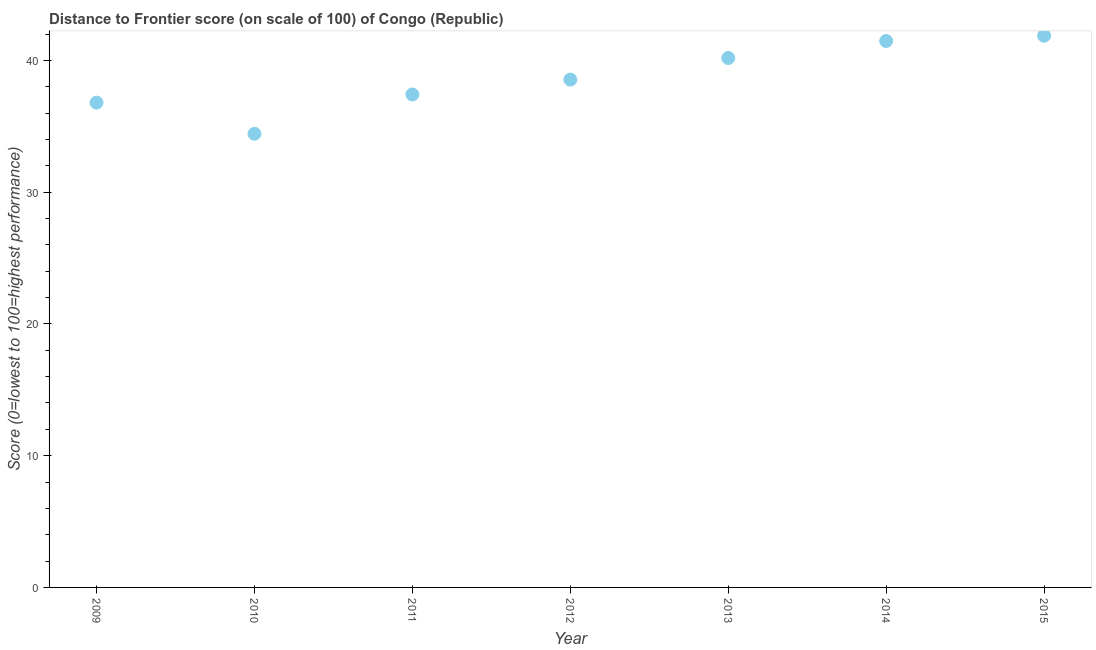What is the distance to frontier score in 2011?
Give a very brief answer. 37.42. Across all years, what is the maximum distance to frontier score?
Make the answer very short. 41.88. Across all years, what is the minimum distance to frontier score?
Provide a short and direct response. 34.44. In which year was the distance to frontier score maximum?
Provide a succinct answer. 2015. What is the sum of the distance to frontier score?
Your response must be concise. 270.76. What is the difference between the distance to frontier score in 2011 and 2014?
Keep it short and to the point. -4.06. What is the average distance to frontier score per year?
Your answer should be compact. 38.68. What is the median distance to frontier score?
Your answer should be very brief. 38.55. In how many years, is the distance to frontier score greater than 4 ?
Give a very brief answer. 7. Do a majority of the years between 2011 and 2013 (inclusive) have distance to frontier score greater than 30 ?
Offer a terse response. Yes. What is the ratio of the distance to frontier score in 2013 to that in 2014?
Your answer should be very brief. 0.97. Is the distance to frontier score in 2011 less than that in 2012?
Provide a succinct answer. Yes. What is the difference between the highest and the second highest distance to frontier score?
Offer a terse response. 0.4. What is the difference between the highest and the lowest distance to frontier score?
Your response must be concise. 7.44. Does the distance to frontier score monotonically increase over the years?
Offer a terse response. No. How many dotlines are there?
Keep it short and to the point. 1. How many years are there in the graph?
Your response must be concise. 7. Does the graph contain any zero values?
Your answer should be compact. No. What is the title of the graph?
Your answer should be very brief. Distance to Frontier score (on scale of 100) of Congo (Republic). What is the label or title of the X-axis?
Give a very brief answer. Year. What is the label or title of the Y-axis?
Make the answer very short. Score (0=lowest to 100=highest performance). What is the Score (0=lowest to 100=highest performance) in 2009?
Provide a succinct answer. 36.8. What is the Score (0=lowest to 100=highest performance) in 2010?
Give a very brief answer. 34.44. What is the Score (0=lowest to 100=highest performance) in 2011?
Offer a terse response. 37.42. What is the Score (0=lowest to 100=highest performance) in 2012?
Keep it short and to the point. 38.55. What is the Score (0=lowest to 100=highest performance) in 2013?
Offer a very short reply. 40.19. What is the Score (0=lowest to 100=highest performance) in 2014?
Provide a succinct answer. 41.48. What is the Score (0=lowest to 100=highest performance) in 2015?
Your answer should be very brief. 41.88. What is the difference between the Score (0=lowest to 100=highest performance) in 2009 and 2010?
Your answer should be compact. 2.36. What is the difference between the Score (0=lowest to 100=highest performance) in 2009 and 2011?
Offer a terse response. -0.62. What is the difference between the Score (0=lowest to 100=highest performance) in 2009 and 2012?
Ensure brevity in your answer.  -1.75. What is the difference between the Score (0=lowest to 100=highest performance) in 2009 and 2013?
Your answer should be compact. -3.39. What is the difference between the Score (0=lowest to 100=highest performance) in 2009 and 2014?
Keep it short and to the point. -4.68. What is the difference between the Score (0=lowest to 100=highest performance) in 2009 and 2015?
Offer a terse response. -5.08. What is the difference between the Score (0=lowest to 100=highest performance) in 2010 and 2011?
Provide a succinct answer. -2.98. What is the difference between the Score (0=lowest to 100=highest performance) in 2010 and 2012?
Offer a terse response. -4.11. What is the difference between the Score (0=lowest to 100=highest performance) in 2010 and 2013?
Offer a terse response. -5.75. What is the difference between the Score (0=lowest to 100=highest performance) in 2010 and 2014?
Your response must be concise. -7.04. What is the difference between the Score (0=lowest to 100=highest performance) in 2010 and 2015?
Give a very brief answer. -7.44. What is the difference between the Score (0=lowest to 100=highest performance) in 2011 and 2012?
Your answer should be very brief. -1.13. What is the difference between the Score (0=lowest to 100=highest performance) in 2011 and 2013?
Offer a terse response. -2.77. What is the difference between the Score (0=lowest to 100=highest performance) in 2011 and 2014?
Ensure brevity in your answer.  -4.06. What is the difference between the Score (0=lowest to 100=highest performance) in 2011 and 2015?
Offer a very short reply. -4.46. What is the difference between the Score (0=lowest to 100=highest performance) in 2012 and 2013?
Ensure brevity in your answer.  -1.64. What is the difference between the Score (0=lowest to 100=highest performance) in 2012 and 2014?
Offer a very short reply. -2.93. What is the difference between the Score (0=lowest to 100=highest performance) in 2012 and 2015?
Your response must be concise. -3.33. What is the difference between the Score (0=lowest to 100=highest performance) in 2013 and 2014?
Offer a very short reply. -1.29. What is the difference between the Score (0=lowest to 100=highest performance) in 2013 and 2015?
Provide a succinct answer. -1.69. What is the difference between the Score (0=lowest to 100=highest performance) in 2014 and 2015?
Offer a terse response. -0.4. What is the ratio of the Score (0=lowest to 100=highest performance) in 2009 to that in 2010?
Your answer should be very brief. 1.07. What is the ratio of the Score (0=lowest to 100=highest performance) in 2009 to that in 2011?
Your response must be concise. 0.98. What is the ratio of the Score (0=lowest to 100=highest performance) in 2009 to that in 2012?
Provide a short and direct response. 0.95. What is the ratio of the Score (0=lowest to 100=highest performance) in 2009 to that in 2013?
Your response must be concise. 0.92. What is the ratio of the Score (0=lowest to 100=highest performance) in 2009 to that in 2014?
Your answer should be very brief. 0.89. What is the ratio of the Score (0=lowest to 100=highest performance) in 2009 to that in 2015?
Your answer should be very brief. 0.88. What is the ratio of the Score (0=lowest to 100=highest performance) in 2010 to that in 2011?
Give a very brief answer. 0.92. What is the ratio of the Score (0=lowest to 100=highest performance) in 2010 to that in 2012?
Ensure brevity in your answer.  0.89. What is the ratio of the Score (0=lowest to 100=highest performance) in 2010 to that in 2013?
Your response must be concise. 0.86. What is the ratio of the Score (0=lowest to 100=highest performance) in 2010 to that in 2014?
Offer a terse response. 0.83. What is the ratio of the Score (0=lowest to 100=highest performance) in 2010 to that in 2015?
Give a very brief answer. 0.82. What is the ratio of the Score (0=lowest to 100=highest performance) in 2011 to that in 2014?
Offer a terse response. 0.9. What is the ratio of the Score (0=lowest to 100=highest performance) in 2011 to that in 2015?
Make the answer very short. 0.89. What is the ratio of the Score (0=lowest to 100=highest performance) in 2012 to that in 2014?
Offer a very short reply. 0.93. What is the ratio of the Score (0=lowest to 100=highest performance) in 2013 to that in 2014?
Your response must be concise. 0.97. What is the ratio of the Score (0=lowest to 100=highest performance) in 2013 to that in 2015?
Your answer should be compact. 0.96. What is the ratio of the Score (0=lowest to 100=highest performance) in 2014 to that in 2015?
Make the answer very short. 0.99. 